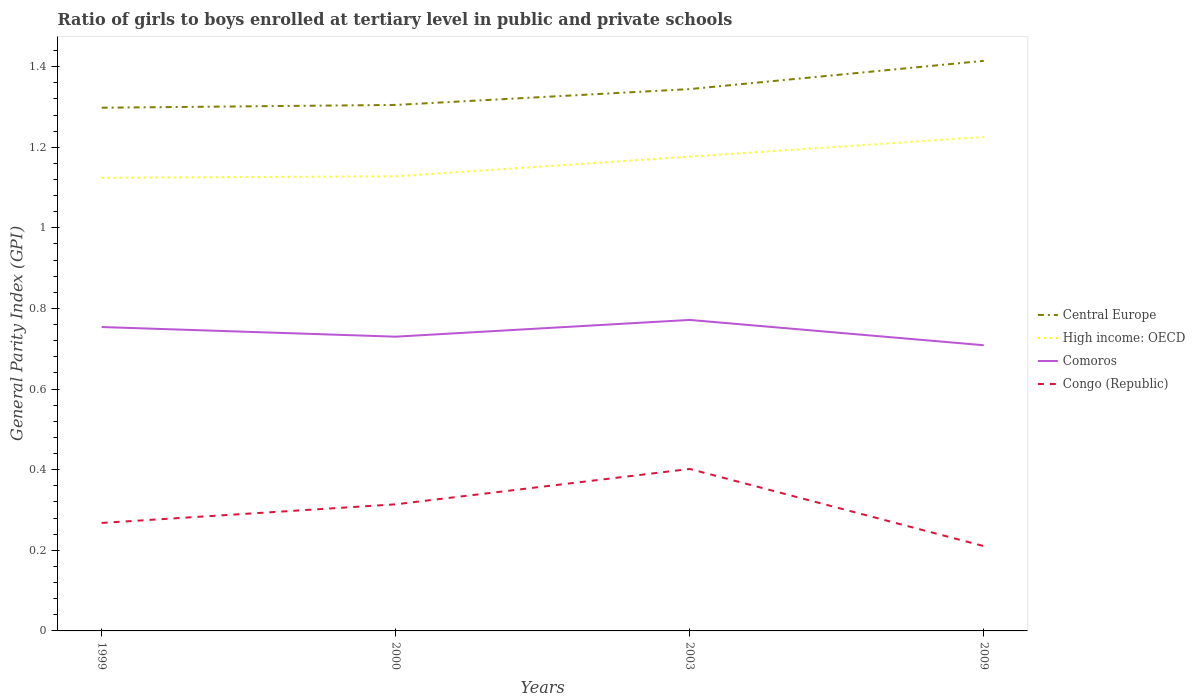Does the line corresponding to Central Europe intersect with the line corresponding to Comoros?
Ensure brevity in your answer.  No. Is the number of lines equal to the number of legend labels?
Provide a short and direct response. Yes. Across all years, what is the maximum general parity index in Comoros?
Your answer should be very brief. 0.71. What is the total general parity index in High income: OECD in the graph?
Your answer should be very brief. -0. What is the difference between the highest and the second highest general parity index in Central Europe?
Offer a terse response. 0.12. What is the difference between the highest and the lowest general parity index in High income: OECD?
Keep it short and to the point. 2. Is the general parity index in Central Europe strictly greater than the general parity index in Congo (Republic) over the years?
Provide a succinct answer. No. How many years are there in the graph?
Make the answer very short. 4. Does the graph contain any zero values?
Give a very brief answer. No. Does the graph contain grids?
Offer a terse response. No. What is the title of the graph?
Offer a terse response. Ratio of girls to boys enrolled at tertiary level in public and private schools. Does "Montenegro" appear as one of the legend labels in the graph?
Provide a short and direct response. No. What is the label or title of the Y-axis?
Ensure brevity in your answer.  General Parity Index (GPI). What is the General Parity Index (GPI) in Central Europe in 1999?
Provide a short and direct response. 1.3. What is the General Parity Index (GPI) of High income: OECD in 1999?
Offer a very short reply. 1.12. What is the General Parity Index (GPI) of Comoros in 1999?
Ensure brevity in your answer.  0.75. What is the General Parity Index (GPI) in Congo (Republic) in 1999?
Offer a terse response. 0.27. What is the General Parity Index (GPI) of Central Europe in 2000?
Your answer should be compact. 1.3. What is the General Parity Index (GPI) of High income: OECD in 2000?
Your response must be concise. 1.13. What is the General Parity Index (GPI) in Comoros in 2000?
Your answer should be very brief. 0.73. What is the General Parity Index (GPI) of Congo (Republic) in 2000?
Offer a very short reply. 0.31. What is the General Parity Index (GPI) in Central Europe in 2003?
Keep it short and to the point. 1.34. What is the General Parity Index (GPI) of High income: OECD in 2003?
Your answer should be compact. 1.18. What is the General Parity Index (GPI) of Comoros in 2003?
Your response must be concise. 0.77. What is the General Parity Index (GPI) of Congo (Republic) in 2003?
Your answer should be compact. 0.4. What is the General Parity Index (GPI) of Central Europe in 2009?
Provide a short and direct response. 1.41. What is the General Parity Index (GPI) in High income: OECD in 2009?
Give a very brief answer. 1.23. What is the General Parity Index (GPI) in Comoros in 2009?
Provide a short and direct response. 0.71. What is the General Parity Index (GPI) in Congo (Republic) in 2009?
Offer a terse response. 0.21. Across all years, what is the maximum General Parity Index (GPI) in Central Europe?
Your answer should be compact. 1.41. Across all years, what is the maximum General Parity Index (GPI) of High income: OECD?
Give a very brief answer. 1.23. Across all years, what is the maximum General Parity Index (GPI) in Comoros?
Make the answer very short. 0.77. Across all years, what is the maximum General Parity Index (GPI) of Congo (Republic)?
Keep it short and to the point. 0.4. Across all years, what is the minimum General Parity Index (GPI) in Central Europe?
Your answer should be compact. 1.3. Across all years, what is the minimum General Parity Index (GPI) in High income: OECD?
Your response must be concise. 1.12. Across all years, what is the minimum General Parity Index (GPI) of Comoros?
Provide a succinct answer. 0.71. Across all years, what is the minimum General Parity Index (GPI) of Congo (Republic)?
Your response must be concise. 0.21. What is the total General Parity Index (GPI) in Central Europe in the graph?
Your answer should be very brief. 5.36. What is the total General Parity Index (GPI) of High income: OECD in the graph?
Keep it short and to the point. 4.65. What is the total General Parity Index (GPI) in Comoros in the graph?
Make the answer very short. 2.96. What is the total General Parity Index (GPI) in Congo (Republic) in the graph?
Ensure brevity in your answer.  1.19. What is the difference between the General Parity Index (GPI) of Central Europe in 1999 and that in 2000?
Your answer should be compact. -0.01. What is the difference between the General Parity Index (GPI) of High income: OECD in 1999 and that in 2000?
Your answer should be very brief. -0. What is the difference between the General Parity Index (GPI) of Comoros in 1999 and that in 2000?
Provide a succinct answer. 0.02. What is the difference between the General Parity Index (GPI) of Congo (Republic) in 1999 and that in 2000?
Provide a short and direct response. -0.05. What is the difference between the General Parity Index (GPI) in Central Europe in 1999 and that in 2003?
Ensure brevity in your answer.  -0.05. What is the difference between the General Parity Index (GPI) in High income: OECD in 1999 and that in 2003?
Your answer should be very brief. -0.05. What is the difference between the General Parity Index (GPI) in Comoros in 1999 and that in 2003?
Your response must be concise. -0.02. What is the difference between the General Parity Index (GPI) in Congo (Republic) in 1999 and that in 2003?
Offer a terse response. -0.13. What is the difference between the General Parity Index (GPI) in Central Europe in 1999 and that in 2009?
Give a very brief answer. -0.12. What is the difference between the General Parity Index (GPI) in High income: OECD in 1999 and that in 2009?
Keep it short and to the point. -0.1. What is the difference between the General Parity Index (GPI) of Comoros in 1999 and that in 2009?
Provide a succinct answer. 0.05. What is the difference between the General Parity Index (GPI) in Congo (Republic) in 1999 and that in 2009?
Offer a terse response. 0.06. What is the difference between the General Parity Index (GPI) in Central Europe in 2000 and that in 2003?
Provide a succinct answer. -0.04. What is the difference between the General Parity Index (GPI) of High income: OECD in 2000 and that in 2003?
Give a very brief answer. -0.05. What is the difference between the General Parity Index (GPI) of Comoros in 2000 and that in 2003?
Offer a terse response. -0.04. What is the difference between the General Parity Index (GPI) of Congo (Republic) in 2000 and that in 2003?
Ensure brevity in your answer.  -0.09. What is the difference between the General Parity Index (GPI) in Central Europe in 2000 and that in 2009?
Ensure brevity in your answer.  -0.11. What is the difference between the General Parity Index (GPI) of High income: OECD in 2000 and that in 2009?
Your answer should be very brief. -0.1. What is the difference between the General Parity Index (GPI) in Comoros in 2000 and that in 2009?
Offer a terse response. 0.02. What is the difference between the General Parity Index (GPI) in Congo (Republic) in 2000 and that in 2009?
Provide a short and direct response. 0.1. What is the difference between the General Parity Index (GPI) of Central Europe in 2003 and that in 2009?
Provide a short and direct response. -0.07. What is the difference between the General Parity Index (GPI) of High income: OECD in 2003 and that in 2009?
Offer a very short reply. -0.05. What is the difference between the General Parity Index (GPI) in Comoros in 2003 and that in 2009?
Ensure brevity in your answer.  0.06. What is the difference between the General Parity Index (GPI) of Congo (Republic) in 2003 and that in 2009?
Your answer should be compact. 0.19. What is the difference between the General Parity Index (GPI) of Central Europe in 1999 and the General Parity Index (GPI) of High income: OECD in 2000?
Your response must be concise. 0.17. What is the difference between the General Parity Index (GPI) of Central Europe in 1999 and the General Parity Index (GPI) of Comoros in 2000?
Your answer should be very brief. 0.57. What is the difference between the General Parity Index (GPI) of Central Europe in 1999 and the General Parity Index (GPI) of Congo (Republic) in 2000?
Ensure brevity in your answer.  0.98. What is the difference between the General Parity Index (GPI) in High income: OECD in 1999 and the General Parity Index (GPI) in Comoros in 2000?
Make the answer very short. 0.39. What is the difference between the General Parity Index (GPI) of High income: OECD in 1999 and the General Parity Index (GPI) of Congo (Republic) in 2000?
Provide a short and direct response. 0.81. What is the difference between the General Parity Index (GPI) of Comoros in 1999 and the General Parity Index (GPI) of Congo (Republic) in 2000?
Provide a short and direct response. 0.44. What is the difference between the General Parity Index (GPI) in Central Europe in 1999 and the General Parity Index (GPI) in High income: OECD in 2003?
Your response must be concise. 0.12. What is the difference between the General Parity Index (GPI) in Central Europe in 1999 and the General Parity Index (GPI) in Comoros in 2003?
Your answer should be very brief. 0.53. What is the difference between the General Parity Index (GPI) in Central Europe in 1999 and the General Parity Index (GPI) in Congo (Republic) in 2003?
Make the answer very short. 0.9. What is the difference between the General Parity Index (GPI) in High income: OECD in 1999 and the General Parity Index (GPI) in Comoros in 2003?
Your response must be concise. 0.35. What is the difference between the General Parity Index (GPI) in High income: OECD in 1999 and the General Parity Index (GPI) in Congo (Republic) in 2003?
Offer a very short reply. 0.72. What is the difference between the General Parity Index (GPI) in Comoros in 1999 and the General Parity Index (GPI) in Congo (Republic) in 2003?
Keep it short and to the point. 0.35. What is the difference between the General Parity Index (GPI) in Central Europe in 1999 and the General Parity Index (GPI) in High income: OECD in 2009?
Provide a short and direct response. 0.07. What is the difference between the General Parity Index (GPI) in Central Europe in 1999 and the General Parity Index (GPI) in Comoros in 2009?
Offer a terse response. 0.59. What is the difference between the General Parity Index (GPI) of Central Europe in 1999 and the General Parity Index (GPI) of Congo (Republic) in 2009?
Provide a succinct answer. 1.09. What is the difference between the General Parity Index (GPI) of High income: OECD in 1999 and the General Parity Index (GPI) of Comoros in 2009?
Offer a very short reply. 0.42. What is the difference between the General Parity Index (GPI) in High income: OECD in 1999 and the General Parity Index (GPI) in Congo (Republic) in 2009?
Make the answer very short. 0.91. What is the difference between the General Parity Index (GPI) in Comoros in 1999 and the General Parity Index (GPI) in Congo (Republic) in 2009?
Offer a terse response. 0.54. What is the difference between the General Parity Index (GPI) of Central Europe in 2000 and the General Parity Index (GPI) of High income: OECD in 2003?
Provide a short and direct response. 0.13. What is the difference between the General Parity Index (GPI) in Central Europe in 2000 and the General Parity Index (GPI) in Comoros in 2003?
Ensure brevity in your answer.  0.53. What is the difference between the General Parity Index (GPI) in Central Europe in 2000 and the General Parity Index (GPI) in Congo (Republic) in 2003?
Make the answer very short. 0.9. What is the difference between the General Parity Index (GPI) in High income: OECD in 2000 and the General Parity Index (GPI) in Comoros in 2003?
Offer a terse response. 0.36. What is the difference between the General Parity Index (GPI) of High income: OECD in 2000 and the General Parity Index (GPI) of Congo (Republic) in 2003?
Your answer should be compact. 0.73. What is the difference between the General Parity Index (GPI) of Comoros in 2000 and the General Parity Index (GPI) of Congo (Republic) in 2003?
Your answer should be very brief. 0.33. What is the difference between the General Parity Index (GPI) in Central Europe in 2000 and the General Parity Index (GPI) in High income: OECD in 2009?
Offer a terse response. 0.08. What is the difference between the General Parity Index (GPI) in Central Europe in 2000 and the General Parity Index (GPI) in Comoros in 2009?
Keep it short and to the point. 0.6. What is the difference between the General Parity Index (GPI) of Central Europe in 2000 and the General Parity Index (GPI) of Congo (Republic) in 2009?
Your answer should be very brief. 1.09. What is the difference between the General Parity Index (GPI) in High income: OECD in 2000 and the General Parity Index (GPI) in Comoros in 2009?
Your response must be concise. 0.42. What is the difference between the General Parity Index (GPI) in High income: OECD in 2000 and the General Parity Index (GPI) in Congo (Republic) in 2009?
Keep it short and to the point. 0.92. What is the difference between the General Parity Index (GPI) of Comoros in 2000 and the General Parity Index (GPI) of Congo (Republic) in 2009?
Your answer should be compact. 0.52. What is the difference between the General Parity Index (GPI) in Central Europe in 2003 and the General Parity Index (GPI) in High income: OECD in 2009?
Your response must be concise. 0.12. What is the difference between the General Parity Index (GPI) of Central Europe in 2003 and the General Parity Index (GPI) of Comoros in 2009?
Ensure brevity in your answer.  0.64. What is the difference between the General Parity Index (GPI) in Central Europe in 2003 and the General Parity Index (GPI) in Congo (Republic) in 2009?
Your answer should be compact. 1.13. What is the difference between the General Parity Index (GPI) of High income: OECD in 2003 and the General Parity Index (GPI) of Comoros in 2009?
Your answer should be very brief. 0.47. What is the difference between the General Parity Index (GPI) of High income: OECD in 2003 and the General Parity Index (GPI) of Congo (Republic) in 2009?
Give a very brief answer. 0.97. What is the difference between the General Parity Index (GPI) in Comoros in 2003 and the General Parity Index (GPI) in Congo (Republic) in 2009?
Make the answer very short. 0.56. What is the average General Parity Index (GPI) of Central Europe per year?
Make the answer very short. 1.34. What is the average General Parity Index (GPI) in High income: OECD per year?
Make the answer very short. 1.16. What is the average General Parity Index (GPI) in Comoros per year?
Provide a short and direct response. 0.74. What is the average General Parity Index (GPI) in Congo (Republic) per year?
Your answer should be very brief. 0.3. In the year 1999, what is the difference between the General Parity Index (GPI) in Central Europe and General Parity Index (GPI) in High income: OECD?
Ensure brevity in your answer.  0.17. In the year 1999, what is the difference between the General Parity Index (GPI) of Central Europe and General Parity Index (GPI) of Comoros?
Offer a very short reply. 0.54. In the year 1999, what is the difference between the General Parity Index (GPI) in Central Europe and General Parity Index (GPI) in Congo (Republic)?
Ensure brevity in your answer.  1.03. In the year 1999, what is the difference between the General Parity Index (GPI) in High income: OECD and General Parity Index (GPI) in Comoros?
Keep it short and to the point. 0.37. In the year 1999, what is the difference between the General Parity Index (GPI) in High income: OECD and General Parity Index (GPI) in Congo (Republic)?
Offer a very short reply. 0.86. In the year 1999, what is the difference between the General Parity Index (GPI) of Comoros and General Parity Index (GPI) of Congo (Republic)?
Provide a succinct answer. 0.49. In the year 2000, what is the difference between the General Parity Index (GPI) of Central Europe and General Parity Index (GPI) of High income: OECD?
Make the answer very short. 0.18. In the year 2000, what is the difference between the General Parity Index (GPI) in Central Europe and General Parity Index (GPI) in Comoros?
Your response must be concise. 0.57. In the year 2000, what is the difference between the General Parity Index (GPI) in Central Europe and General Parity Index (GPI) in Congo (Republic)?
Make the answer very short. 0.99. In the year 2000, what is the difference between the General Parity Index (GPI) of High income: OECD and General Parity Index (GPI) of Comoros?
Your response must be concise. 0.4. In the year 2000, what is the difference between the General Parity Index (GPI) in High income: OECD and General Parity Index (GPI) in Congo (Republic)?
Offer a terse response. 0.81. In the year 2000, what is the difference between the General Parity Index (GPI) in Comoros and General Parity Index (GPI) in Congo (Republic)?
Offer a terse response. 0.42. In the year 2003, what is the difference between the General Parity Index (GPI) in Central Europe and General Parity Index (GPI) in High income: OECD?
Your answer should be very brief. 0.17. In the year 2003, what is the difference between the General Parity Index (GPI) of Central Europe and General Parity Index (GPI) of Comoros?
Your response must be concise. 0.57. In the year 2003, what is the difference between the General Parity Index (GPI) in Central Europe and General Parity Index (GPI) in Congo (Republic)?
Keep it short and to the point. 0.94. In the year 2003, what is the difference between the General Parity Index (GPI) in High income: OECD and General Parity Index (GPI) in Comoros?
Make the answer very short. 0.41. In the year 2003, what is the difference between the General Parity Index (GPI) of High income: OECD and General Parity Index (GPI) of Congo (Republic)?
Offer a terse response. 0.77. In the year 2003, what is the difference between the General Parity Index (GPI) of Comoros and General Parity Index (GPI) of Congo (Republic)?
Provide a succinct answer. 0.37. In the year 2009, what is the difference between the General Parity Index (GPI) in Central Europe and General Parity Index (GPI) in High income: OECD?
Your response must be concise. 0.19. In the year 2009, what is the difference between the General Parity Index (GPI) of Central Europe and General Parity Index (GPI) of Comoros?
Ensure brevity in your answer.  0.71. In the year 2009, what is the difference between the General Parity Index (GPI) of Central Europe and General Parity Index (GPI) of Congo (Republic)?
Make the answer very short. 1.2. In the year 2009, what is the difference between the General Parity Index (GPI) in High income: OECD and General Parity Index (GPI) in Comoros?
Offer a terse response. 0.52. In the year 2009, what is the difference between the General Parity Index (GPI) of High income: OECD and General Parity Index (GPI) of Congo (Republic)?
Offer a terse response. 1.01. In the year 2009, what is the difference between the General Parity Index (GPI) of Comoros and General Parity Index (GPI) of Congo (Republic)?
Ensure brevity in your answer.  0.5. What is the ratio of the General Parity Index (GPI) of Central Europe in 1999 to that in 2000?
Your answer should be compact. 0.99. What is the ratio of the General Parity Index (GPI) in High income: OECD in 1999 to that in 2000?
Give a very brief answer. 1. What is the ratio of the General Parity Index (GPI) of Comoros in 1999 to that in 2000?
Offer a very short reply. 1.03. What is the ratio of the General Parity Index (GPI) of Congo (Republic) in 1999 to that in 2000?
Your answer should be very brief. 0.85. What is the ratio of the General Parity Index (GPI) in Central Europe in 1999 to that in 2003?
Make the answer very short. 0.97. What is the ratio of the General Parity Index (GPI) in High income: OECD in 1999 to that in 2003?
Your response must be concise. 0.96. What is the ratio of the General Parity Index (GPI) of Comoros in 1999 to that in 2003?
Offer a very short reply. 0.98. What is the ratio of the General Parity Index (GPI) of Central Europe in 1999 to that in 2009?
Your answer should be compact. 0.92. What is the ratio of the General Parity Index (GPI) in High income: OECD in 1999 to that in 2009?
Your answer should be very brief. 0.92. What is the ratio of the General Parity Index (GPI) of Comoros in 1999 to that in 2009?
Ensure brevity in your answer.  1.06. What is the ratio of the General Parity Index (GPI) of Congo (Republic) in 1999 to that in 2009?
Make the answer very short. 1.27. What is the ratio of the General Parity Index (GPI) in Central Europe in 2000 to that in 2003?
Give a very brief answer. 0.97. What is the ratio of the General Parity Index (GPI) of High income: OECD in 2000 to that in 2003?
Offer a very short reply. 0.96. What is the ratio of the General Parity Index (GPI) of Comoros in 2000 to that in 2003?
Offer a very short reply. 0.95. What is the ratio of the General Parity Index (GPI) in Congo (Republic) in 2000 to that in 2003?
Give a very brief answer. 0.78. What is the ratio of the General Parity Index (GPI) in Central Europe in 2000 to that in 2009?
Make the answer very short. 0.92. What is the ratio of the General Parity Index (GPI) of High income: OECD in 2000 to that in 2009?
Give a very brief answer. 0.92. What is the ratio of the General Parity Index (GPI) in Comoros in 2000 to that in 2009?
Keep it short and to the point. 1.03. What is the ratio of the General Parity Index (GPI) of Congo (Republic) in 2000 to that in 2009?
Give a very brief answer. 1.49. What is the ratio of the General Parity Index (GPI) of Central Europe in 2003 to that in 2009?
Your answer should be very brief. 0.95. What is the ratio of the General Parity Index (GPI) in High income: OECD in 2003 to that in 2009?
Offer a terse response. 0.96. What is the ratio of the General Parity Index (GPI) of Comoros in 2003 to that in 2009?
Your answer should be very brief. 1.09. What is the ratio of the General Parity Index (GPI) in Congo (Republic) in 2003 to that in 2009?
Make the answer very short. 1.91. What is the difference between the highest and the second highest General Parity Index (GPI) in Central Europe?
Ensure brevity in your answer.  0.07. What is the difference between the highest and the second highest General Parity Index (GPI) in High income: OECD?
Offer a very short reply. 0.05. What is the difference between the highest and the second highest General Parity Index (GPI) in Comoros?
Offer a very short reply. 0.02. What is the difference between the highest and the second highest General Parity Index (GPI) in Congo (Republic)?
Ensure brevity in your answer.  0.09. What is the difference between the highest and the lowest General Parity Index (GPI) of Central Europe?
Ensure brevity in your answer.  0.12. What is the difference between the highest and the lowest General Parity Index (GPI) in High income: OECD?
Provide a short and direct response. 0.1. What is the difference between the highest and the lowest General Parity Index (GPI) in Comoros?
Ensure brevity in your answer.  0.06. What is the difference between the highest and the lowest General Parity Index (GPI) in Congo (Republic)?
Offer a terse response. 0.19. 